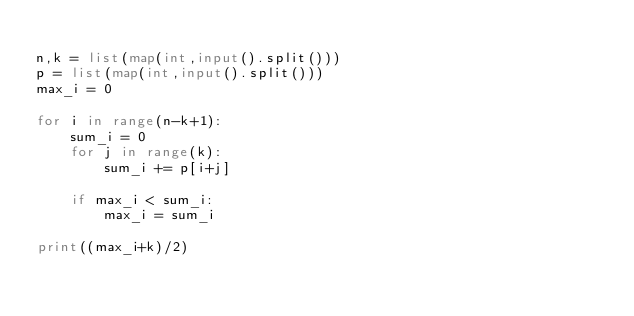Convert code to text. <code><loc_0><loc_0><loc_500><loc_500><_Python_>
n,k = list(map(int,input().split()))
p = list(map(int,input().split()))
max_i = 0

for i in range(n-k+1):
    sum_i = 0
    for j in range(k):
        sum_i += p[i+j]
    
    if max_i < sum_i:
        max_i = sum_i

print((max_i+k)/2)
    
    </code> 